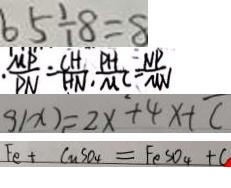<formula> <loc_0><loc_0><loc_500><loc_500>6 5 \div 8 = 8 
 \frac { M P } { P N } = \frac { C H } { H N } \cdot \frac { P H } { M C } = \frac { N P } { M N } 
 g ( x ) = 2 x ^ { 2 } + 4 x + c 
 F e + C u S O _ { 4 } = F e S O _ { 4 } + C</formula> 